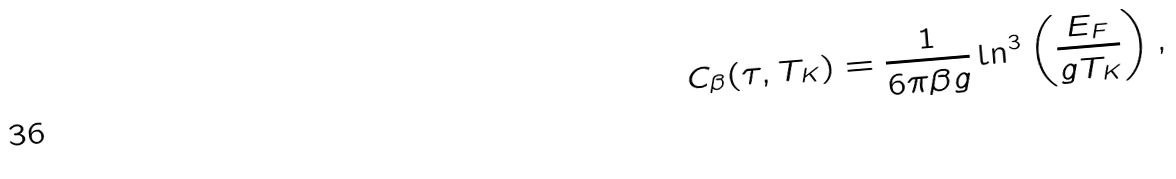Convert formula to latex. <formula><loc_0><loc_0><loc_500><loc_500>C _ { \beta } ( \tau , T _ { K } ) = \frac { 1 } { 6 \pi \beta g } \ln ^ { 3 } \left ( \frac { E _ { F } } { g T _ { K } } \right ) ,</formula> 